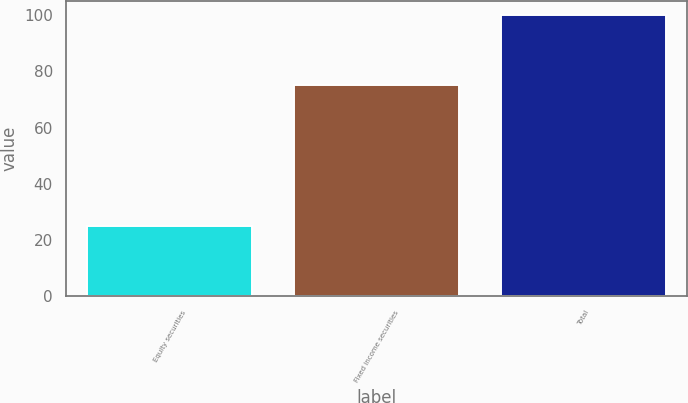<chart> <loc_0><loc_0><loc_500><loc_500><bar_chart><fcel>Equity securities<fcel>Fixed income securities<fcel>Total<nl><fcel>25<fcel>75<fcel>100<nl></chart> 